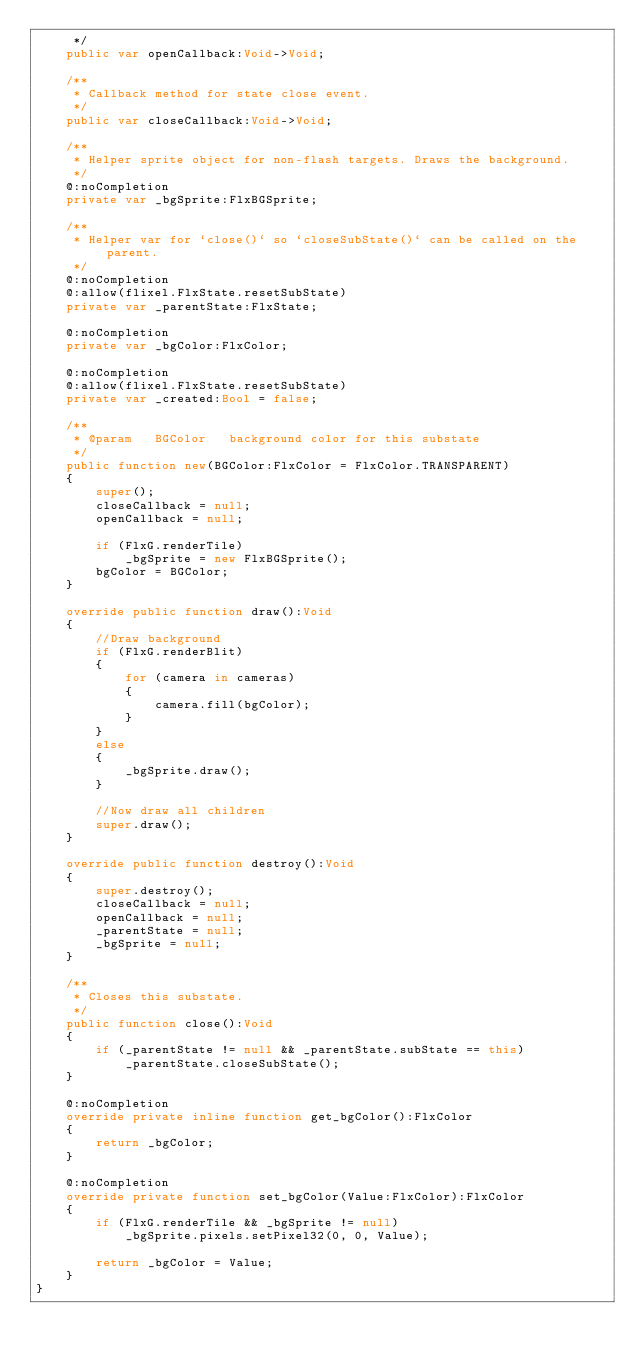Convert code to text. <code><loc_0><loc_0><loc_500><loc_500><_Haxe_>	 */
	public var openCallback:Void->Void;

	/**
	 * Callback method for state close event.
	 */
	public var closeCallback:Void->Void;
	
	/**
	 * Helper sprite object for non-flash targets. Draws the background.
	 */
	@:noCompletion
	private var _bgSprite:FlxBGSprite;
	
	/**
	 * Helper var for `close()` so `closeSubState()` can be called on the parent.
	 */
	@:noCompletion
	@:allow(flixel.FlxState.resetSubState)
	private var _parentState:FlxState;
	
	@:noCompletion
	private var _bgColor:FlxColor;

	@:noCompletion
	@:allow(flixel.FlxState.resetSubState)
	private var _created:Bool = false;
	
	/**
	 * @param   BGColor   background color for this substate
	 */
	public function new(BGColor:FlxColor = FlxColor.TRANSPARENT)
	{
		super();
		closeCallback = null;
		openCallback = null;
		
		if (FlxG.renderTile)
			_bgSprite = new FlxBGSprite();
		bgColor = BGColor;
	}
	
	override public function draw():Void
	{
		//Draw background
		if (FlxG.renderBlit)
		{
			for (camera in cameras)
			{
				camera.fill(bgColor);
			}
		}
		else
		{
			_bgSprite.draw();
		}
		
		//Now draw all children
		super.draw();
	}
	
	override public function destroy():Void 
	{
		super.destroy();
		closeCallback = null;
		openCallback = null;
		_parentState = null;
		_bgSprite = null;
	}
	
	/**
	 * Closes this substate.
	 */
	public function close():Void
	{
		if (_parentState != null && _parentState.subState == this)
			_parentState.closeSubState();
	}
	
	@:noCompletion
	override private inline function get_bgColor():FlxColor
	{
		return _bgColor;
	}
	
	@:noCompletion
	override private function set_bgColor(Value:FlxColor):FlxColor
	{
		if (FlxG.renderTile && _bgSprite != null)
			_bgSprite.pixels.setPixel32(0, 0, Value);
		
		return _bgColor = Value;
	}
}</code> 